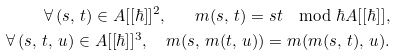Convert formula to latex. <formula><loc_0><loc_0><loc_500><loc_500>\forall \, ( s , \, t ) \in A [ [ \hbar { ] } ] ^ { 2 } , \quad m ( s , \, t ) = s t \mod \hbar { A } [ [ \hbar { ] } ] , \\ \forall \, ( s , \, t , \, u ) \in A [ [ \hbar { ] } ] ^ { 3 } , \quad m ( s , \, m ( t , \, u ) ) = m ( m ( s , \, t ) , \, u ) .</formula> 